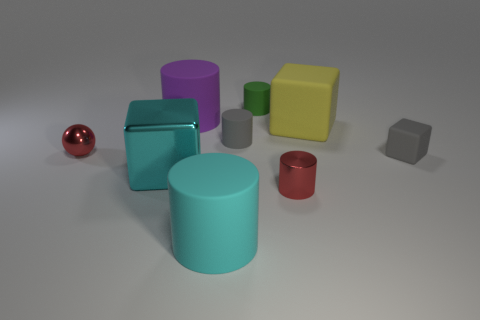There is a large cylinder that is behind the metal block; how many large rubber cubes are behind it?
Offer a terse response. 0. Do the large cyan cylinder and the large yellow cube have the same material?
Offer a terse response. Yes. What is the size of the sphere that is the same color as the tiny metallic cylinder?
Your answer should be compact. Small. Is there a brown thing that has the same material as the cyan block?
Provide a short and direct response. No. What is the color of the thing right of the yellow cube that is behind the tiny gray object behind the tiny red ball?
Keep it short and to the point. Gray. How many cyan objects are objects or big metallic balls?
Your answer should be very brief. 2. What number of large cyan metallic objects are the same shape as the yellow rubber object?
Offer a very short reply. 1. There is a green thing that is the same size as the red sphere; what is its shape?
Provide a short and direct response. Cylinder. There is a tiny ball; are there any red metal objects on the right side of it?
Your answer should be compact. Yes. There is a tiny matte cylinder in front of the green object; are there any tiny metallic things right of it?
Ensure brevity in your answer.  Yes. 